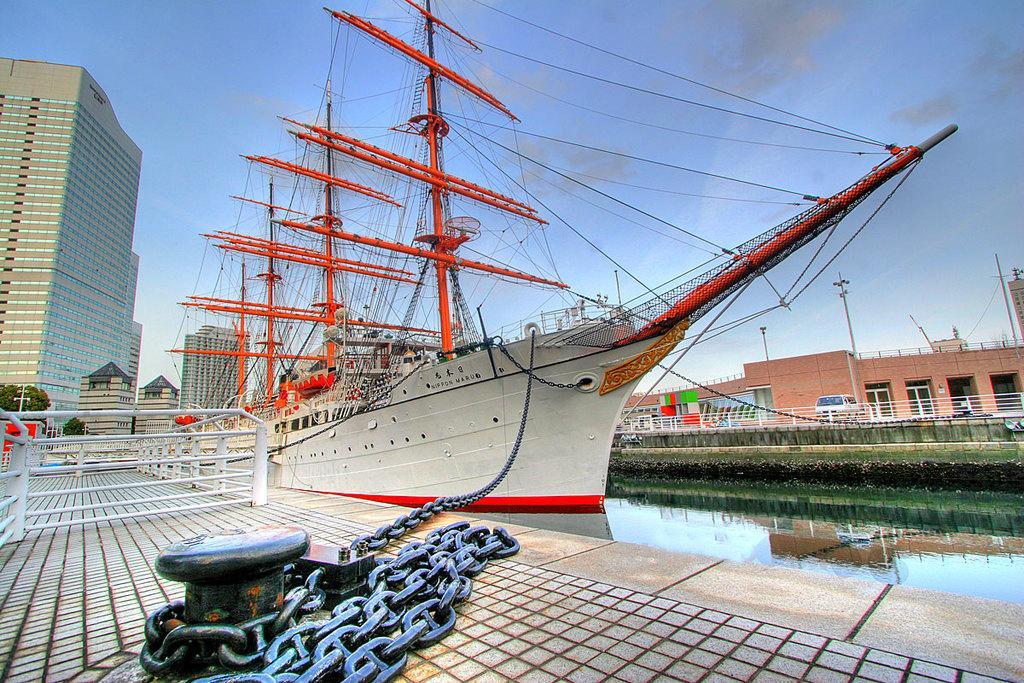In one or two sentences, can you explain what this image depicts? In this image I can see the water. On the left side I can see the chain and the rail. I can also see the ship. In the background, I can see the buildings and clouds in the sky. 